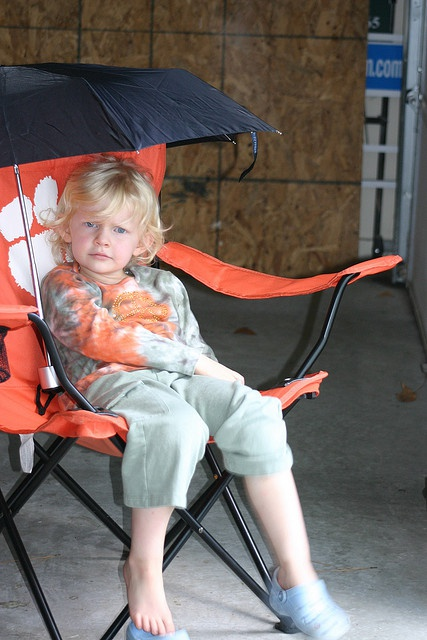Describe the objects in this image and their specific colors. I can see chair in maroon, black, gray, salmon, and darkgray tones, people in maroon, white, darkgray, lightpink, and gray tones, and umbrella in black, darkblue, and gray tones in this image. 